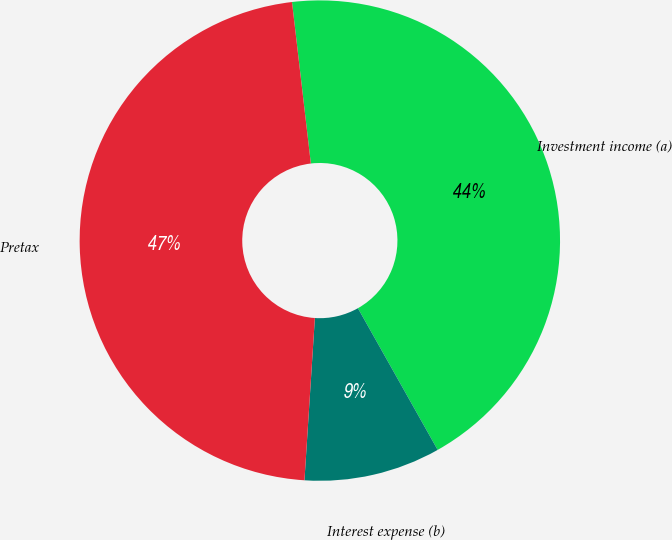Convert chart. <chart><loc_0><loc_0><loc_500><loc_500><pie_chart><fcel>Investment income (a)<fcel>Interest expense (b)<fcel>Pretax<nl><fcel>43.69%<fcel>9.18%<fcel>47.13%<nl></chart> 